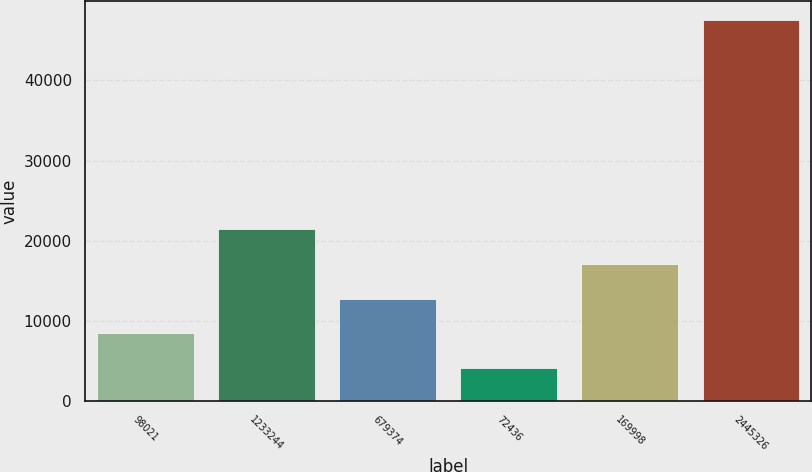Convert chart. <chart><loc_0><loc_0><loc_500><loc_500><bar_chart><fcel>98021<fcel>1233244<fcel>679374<fcel>72436<fcel>169998<fcel>2445326<nl><fcel>8459.3<fcel>21489.2<fcel>12802.6<fcel>4116<fcel>17145.9<fcel>47549<nl></chart> 